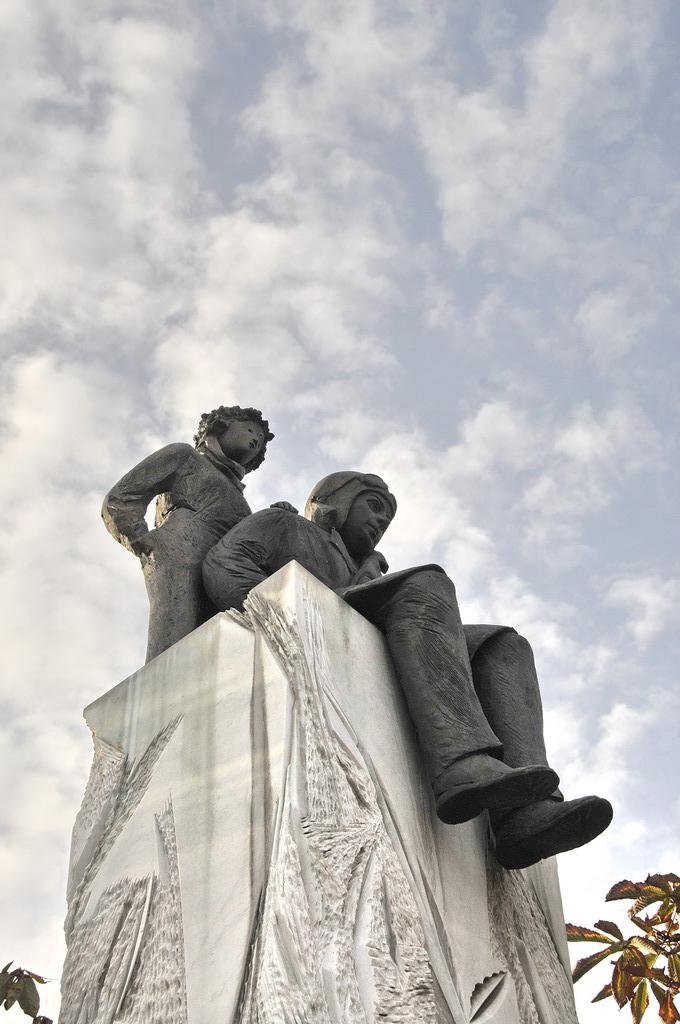What is the color of the object in the image? The object in the image is white. What is on the white object? There are two sculptures on the white object. What type of vegetation is present in the image? Leaves are present in the image}. What is visible in the sky in the image? Clouds and the sky are visible in the image. What type of jam is being spread on the sculptures in the image? There is no jam present in the image, and the sculptures are not being spread with any substance. 